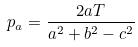Convert formula to latex. <formula><loc_0><loc_0><loc_500><loc_500>p _ { a } = \frac { 2 a T } { a ^ { 2 } + b ^ { 2 } - c ^ { 2 } }</formula> 